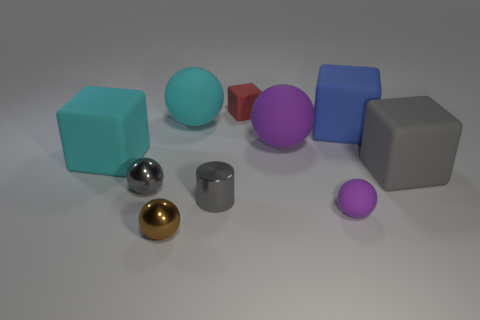Subtract 1 blocks. How many blocks are left? 3 Subtract all blue balls. Subtract all red cylinders. How many balls are left? 5 Subtract all cubes. How many objects are left? 6 Add 5 purple things. How many purple things exist? 7 Subtract 0 yellow balls. How many objects are left? 10 Subtract all rubber blocks. Subtract all green spheres. How many objects are left? 6 Add 1 large purple objects. How many large purple objects are left? 2 